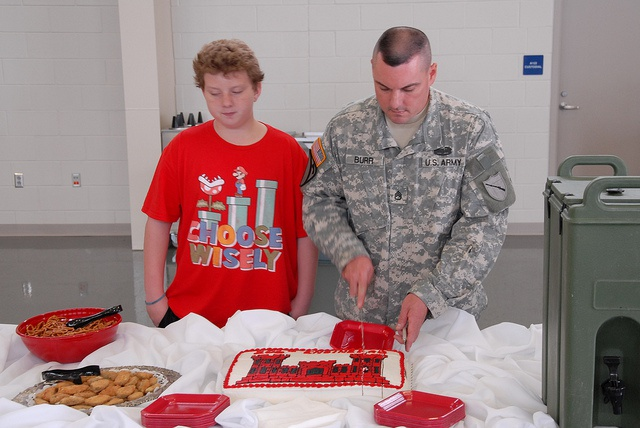Describe the objects in this image and their specific colors. I can see people in darkgray, gray, and black tones, people in darkgray and brown tones, cake in darkgray, lightgray, and brown tones, bowl in darkgray, brown, and maroon tones, and bowl in darkgray and brown tones in this image. 